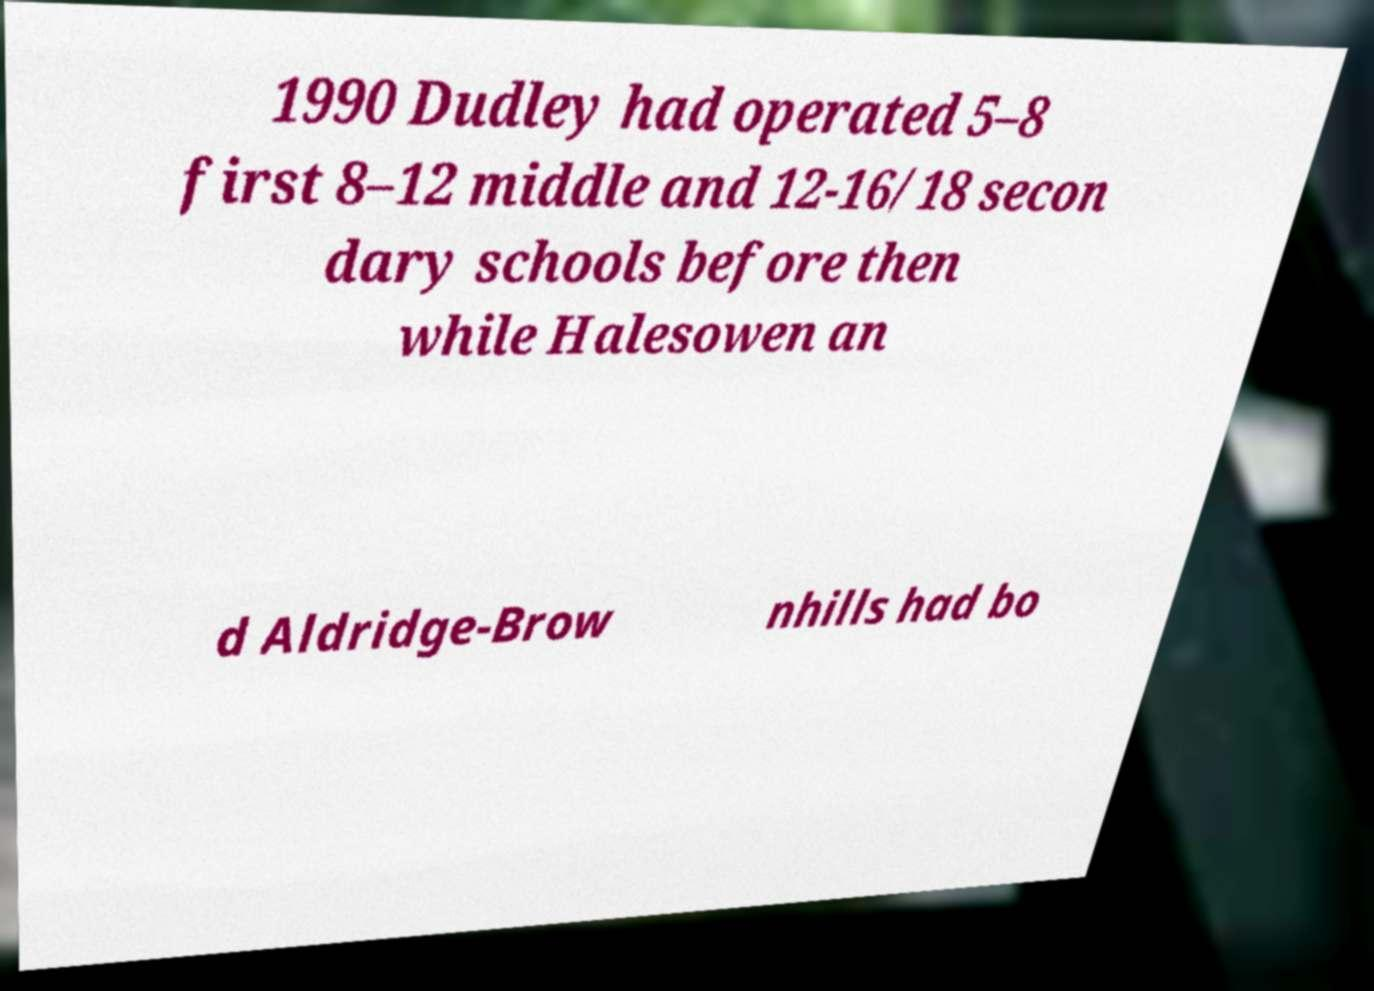Can you read and provide the text displayed in the image?This photo seems to have some interesting text. Can you extract and type it out for me? 1990 Dudley had operated 5–8 first 8–12 middle and 12-16/18 secon dary schools before then while Halesowen an d Aldridge-Brow nhills had bo 